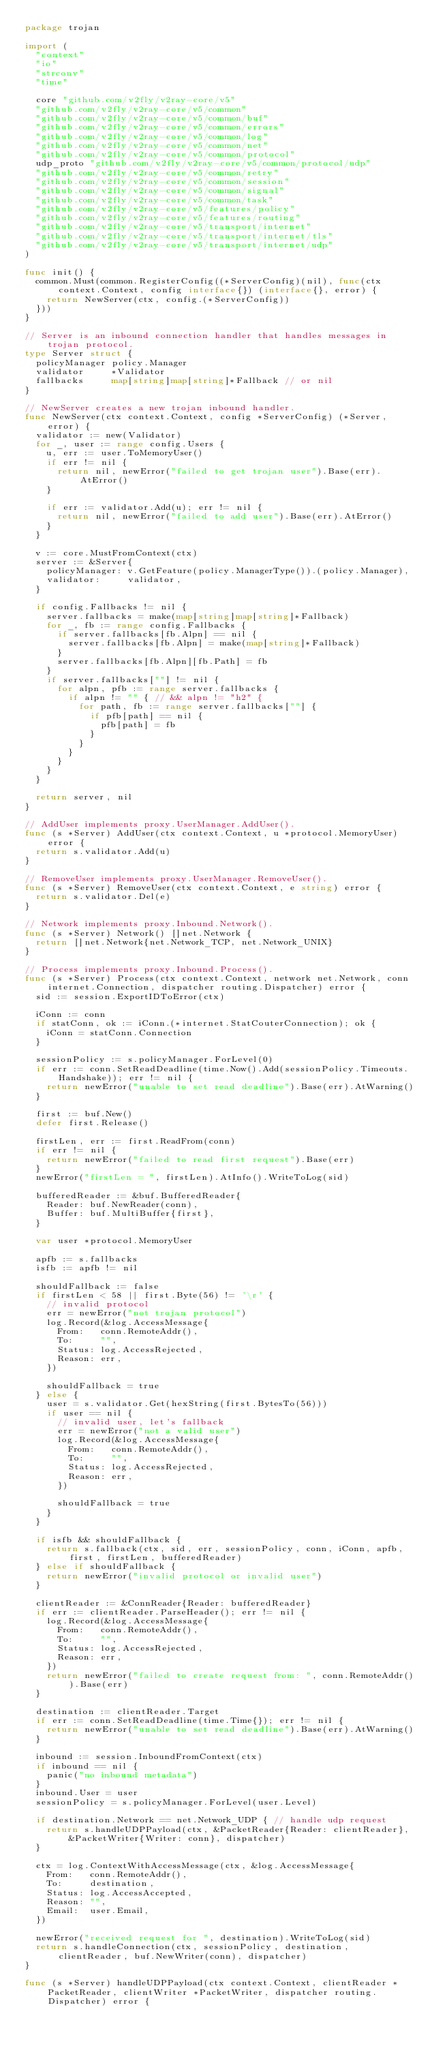Convert code to text. <code><loc_0><loc_0><loc_500><loc_500><_Go_>package trojan

import (
	"context"
	"io"
	"strconv"
	"time"

	core "github.com/v2fly/v2ray-core/v5"
	"github.com/v2fly/v2ray-core/v5/common"
	"github.com/v2fly/v2ray-core/v5/common/buf"
	"github.com/v2fly/v2ray-core/v5/common/errors"
	"github.com/v2fly/v2ray-core/v5/common/log"
	"github.com/v2fly/v2ray-core/v5/common/net"
	"github.com/v2fly/v2ray-core/v5/common/protocol"
	udp_proto "github.com/v2fly/v2ray-core/v5/common/protocol/udp"
	"github.com/v2fly/v2ray-core/v5/common/retry"
	"github.com/v2fly/v2ray-core/v5/common/session"
	"github.com/v2fly/v2ray-core/v5/common/signal"
	"github.com/v2fly/v2ray-core/v5/common/task"
	"github.com/v2fly/v2ray-core/v5/features/policy"
	"github.com/v2fly/v2ray-core/v5/features/routing"
	"github.com/v2fly/v2ray-core/v5/transport/internet"
	"github.com/v2fly/v2ray-core/v5/transport/internet/tls"
	"github.com/v2fly/v2ray-core/v5/transport/internet/udp"
)

func init() {
	common.Must(common.RegisterConfig((*ServerConfig)(nil), func(ctx context.Context, config interface{}) (interface{}, error) {
		return NewServer(ctx, config.(*ServerConfig))
	}))
}

// Server is an inbound connection handler that handles messages in trojan protocol.
type Server struct {
	policyManager policy.Manager
	validator     *Validator
	fallbacks     map[string]map[string]*Fallback // or nil
}

// NewServer creates a new trojan inbound handler.
func NewServer(ctx context.Context, config *ServerConfig) (*Server, error) {
	validator := new(Validator)
	for _, user := range config.Users {
		u, err := user.ToMemoryUser()
		if err != nil {
			return nil, newError("failed to get trojan user").Base(err).AtError()
		}

		if err := validator.Add(u); err != nil {
			return nil, newError("failed to add user").Base(err).AtError()
		}
	}

	v := core.MustFromContext(ctx)
	server := &Server{
		policyManager: v.GetFeature(policy.ManagerType()).(policy.Manager),
		validator:     validator,
	}

	if config.Fallbacks != nil {
		server.fallbacks = make(map[string]map[string]*Fallback)
		for _, fb := range config.Fallbacks {
			if server.fallbacks[fb.Alpn] == nil {
				server.fallbacks[fb.Alpn] = make(map[string]*Fallback)
			}
			server.fallbacks[fb.Alpn][fb.Path] = fb
		}
		if server.fallbacks[""] != nil {
			for alpn, pfb := range server.fallbacks {
				if alpn != "" { // && alpn != "h2" {
					for path, fb := range server.fallbacks[""] {
						if pfb[path] == nil {
							pfb[path] = fb
						}
					}
				}
			}
		}
	}

	return server, nil
}

// AddUser implements proxy.UserManager.AddUser().
func (s *Server) AddUser(ctx context.Context, u *protocol.MemoryUser) error {
	return s.validator.Add(u)
}

// RemoveUser implements proxy.UserManager.RemoveUser().
func (s *Server) RemoveUser(ctx context.Context, e string) error {
	return s.validator.Del(e)
}

// Network implements proxy.Inbound.Network().
func (s *Server) Network() []net.Network {
	return []net.Network{net.Network_TCP, net.Network_UNIX}
}

// Process implements proxy.Inbound.Process().
func (s *Server) Process(ctx context.Context, network net.Network, conn internet.Connection, dispatcher routing.Dispatcher) error {
	sid := session.ExportIDToError(ctx)

	iConn := conn
	if statConn, ok := iConn.(*internet.StatCouterConnection); ok {
		iConn = statConn.Connection
	}

	sessionPolicy := s.policyManager.ForLevel(0)
	if err := conn.SetReadDeadline(time.Now().Add(sessionPolicy.Timeouts.Handshake)); err != nil {
		return newError("unable to set read deadline").Base(err).AtWarning()
	}

	first := buf.New()
	defer first.Release()

	firstLen, err := first.ReadFrom(conn)
	if err != nil {
		return newError("failed to read first request").Base(err)
	}
	newError("firstLen = ", firstLen).AtInfo().WriteToLog(sid)

	bufferedReader := &buf.BufferedReader{
		Reader: buf.NewReader(conn),
		Buffer: buf.MultiBuffer{first},
	}

	var user *protocol.MemoryUser

	apfb := s.fallbacks
	isfb := apfb != nil

	shouldFallback := false
	if firstLen < 58 || first.Byte(56) != '\r' {
		// invalid protocol
		err = newError("not trojan protocol")
		log.Record(&log.AccessMessage{
			From:   conn.RemoteAddr(),
			To:     "",
			Status: log.AccessRejected,
			Reason: err,
		})

		shouldFallback = true
	} else {
		user = s.validator.Get(hexString(first.BytesTo(56)))
		if user == nil {
			// invalid user, let's fallback
			err = newError("not a valid user")
			log.Record(&log.AccessMessage{
				From:   conn.RemoteAddr(),
				To:     "",
				Status: log.AccessRejected,
				Reason: err,
			})

			shouldFallback = true
		}
	}

	if isfb && shouldFallback {
		return s.fallback(ctx, sid, err, sessionPolicy, conn, iConn, apfb, first, firstLen, bufferedReader)
	} else if shouldFallback {
		return newError("invalid protocol or invalid user")
	}

	clientReader := &ConnReader{Reader: bufferedReader}
	if err := clientReader.ParseHeader(); err != nil {
		log.Record(&log.AccessMessage{
			From:   conn.RemoteAddr(),
			To:     "",
			Status: log.AccessRejected,
			Reason: err,
		})
		return newError("failed to create request from: ", conn.RemoteAddr()).Base(err)
	}

	destination := clientReader.Target
	if err := conn.SetReadDeadline(time.Time{}); err != nil {
		return newError("unable to set read deadline").Base(err).AtWarning()
	}

	inbound := session.InboundFromContext(ctx)
	if inbound == nil {
		panic("no inbound metadata")
	}
	inbound.User = user
	sessionPolicy = s.policyManager.ForLevel(user.Level)

	if destination.Network == net.Network_UDP { // handle udp request
		return s.handleUDPPayload(ctx, &PacketReader{Reader: clientReader}, &PacketWriter{Writer: conn}, dispatcher)
	}

	ctx = log.ContextWithAccessMessage(ctx, &log.AccessMessage{
		From:   conn.RemoteAddr(),
		To:     destination,
		Status: log.AccessAccepted,
		Reason: "",
		Email:  user.Email,
	})

	newError("received request for ", destination).WriteToLog(sid)
	return s.handleConnection(ctx, sessionPolicy, destination, clientReader, buf.NewWriter(conn), dispatcher)
}

func (s *Server) handleUDPPayload(ctx context.Context, clientReader *PacketReader, clientWriter *PacketWriter, dispatcher routing.Dispatcher) error {</code> 